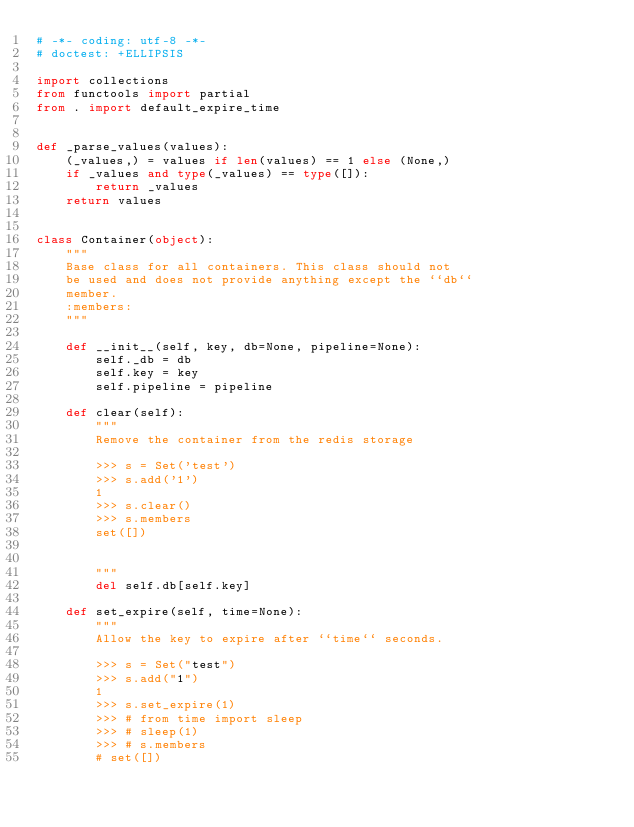<code> <loc_0><loc_0><loc_500><loc_500><_Python_># -*- coding: utf-8 -*-
# doctest: +ELLIPSIS

import collections
from functools import partial
from . import default_expire_time


def _parse_values(values):
    (_values,) = values if len(values) == 1 else (None,)
    if _values and type(_values) == type([]):
        return _values
    return values


class Container(object):
    """
    Base class for all containers. This class should not
    be used and does not provide anything except the ``db``
    member.
    :members:
    """

    def __init__(self, key, db=None, pipeline=None):
        self._db = db
        self.key = key
        self.pipeline = pipeline

    def clear(self):
        """
        Remove the container from the redis storage

        >>> s = Set('test')
        >>> s.add('1')
        1
        >>> s.clear()
        >>> s.members
        set([])


        """
        del self.db[self.key]

    def set_expire(self, time=None):
        """
        Allow the key to expire after ``time`` seconds.

        >>> s = Set("test")
        >>> s.add("1")
        1
        >>> s.set_expire(1)
        >>> # from time import sleep
        >>> # sleep(1)
        >>> # s.members
        # set([])</code> 